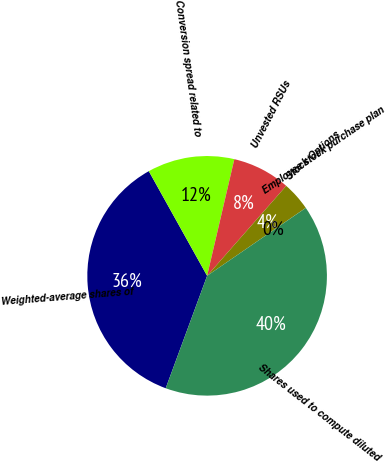<chart> <loc_0><loc_0><loc_500><loc_500><pie_chart><fcel>Weighted-average shares of<fcel>Conversion spread related to<fcel>Unvested RSUs<fcel>Stock Options<fcel>Employee stock purchase plan<fcel>Shares used to compute diluted<nl><fcel>36.3%<fcel>11.74%<fcel>7.83%<fcel>3.92%<fcel>0.01%<fcel>40.21%<nl></chart> 